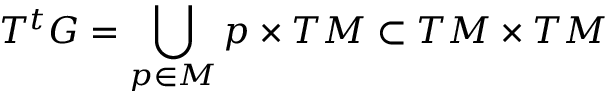Convert formula to latex. <formula><loc_0><loc_0><loc_500><loc_500>T ^ { t } G = \bigcup _ { p \in M } p \times T M \subset T M \times T M</formula> 